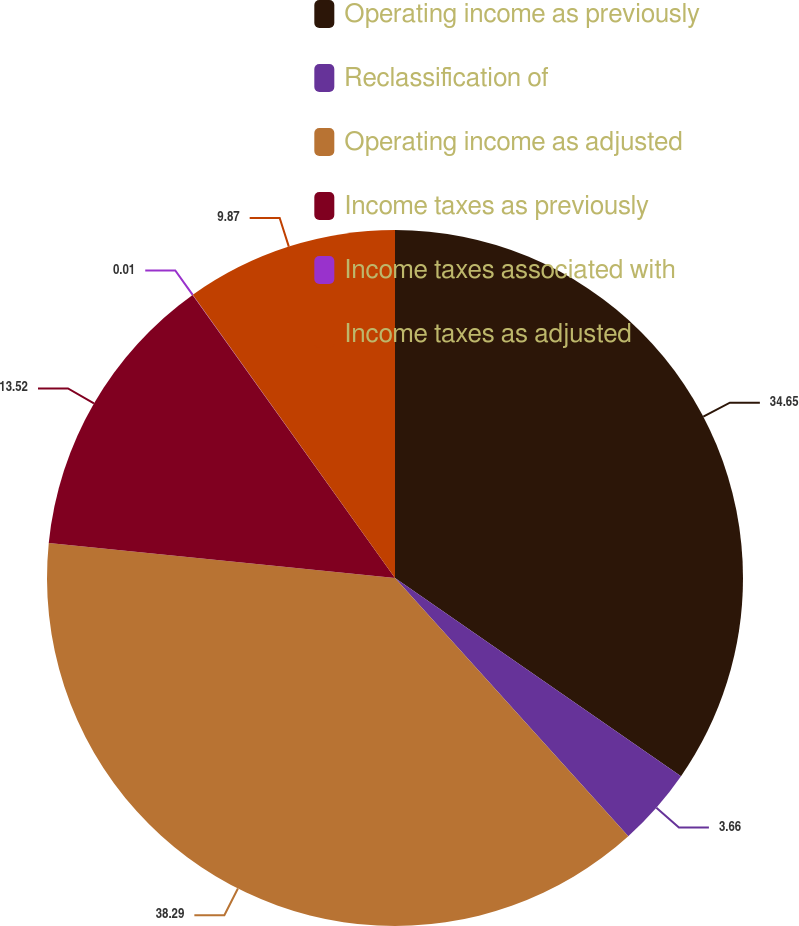<chart> <loc_0><loc_0><loc_500><loc_500><pie_chart><fcel>Operating income as previously<fcel>Reclassification of<fcel>Operating income as adjusted<fcel>Income taxes as previously<fcel>Income taxes associated with<fcel>Income taxes as adjusted<nl><fcel>34.65%<fcel>3.66%<fcel>38.3%<fcel>13.52%<fcel>0.01%<fcel>9.87%<nl></chart> 